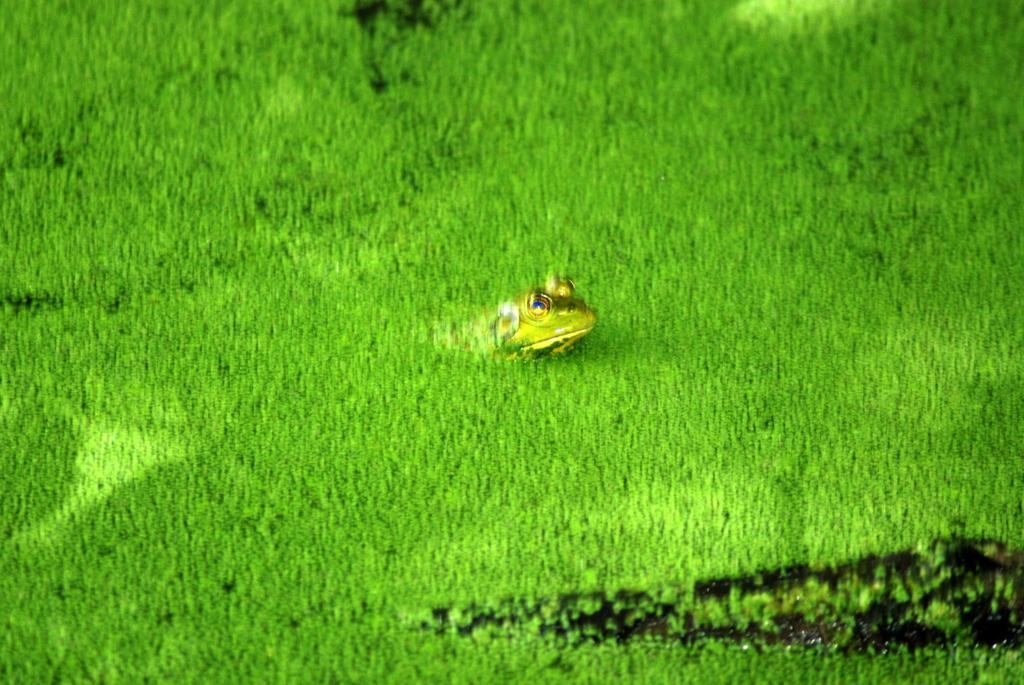What type of animal can be seen in the grass in the image? There is a frog in the grass in the image. What can be seen on the right side of the image? There is a black color thing on the right side of the image. What type of table is visible in the image? There is no table present in the image. How many toes does the frog have in the image? The number of toes on the frog cannot be determined from the image. 